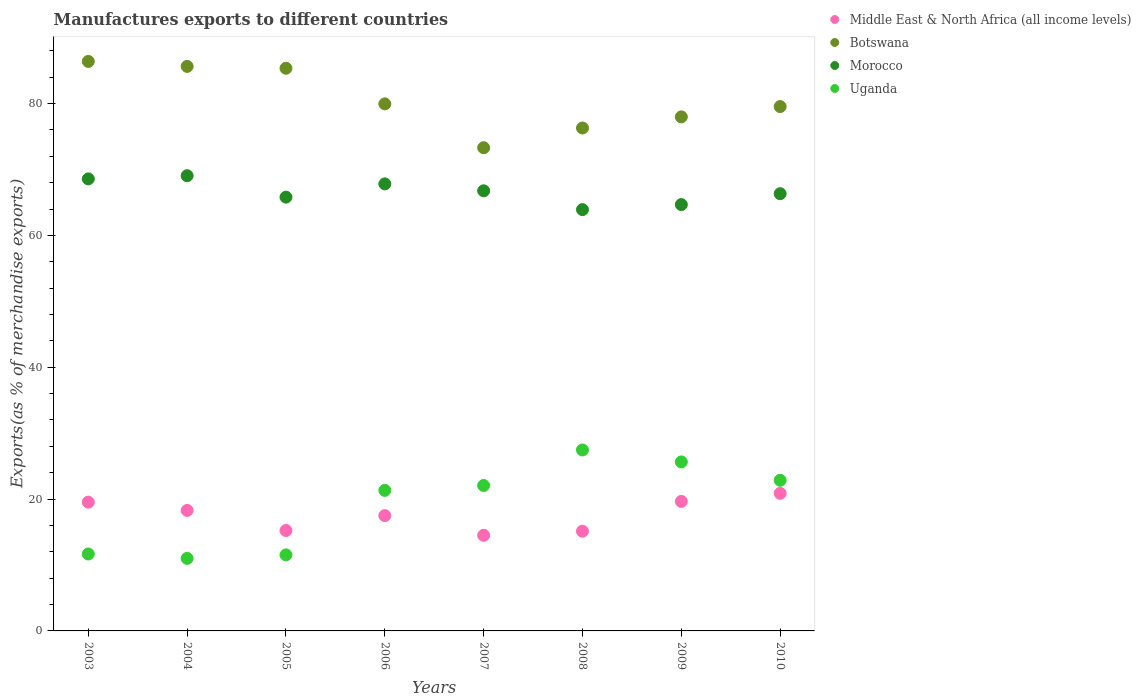Is the number of dotlines equal to the number of legend labels?
Give a very brief answer. Yes. What is the percentage of exports to different countries in Botswana in 2007?
Your answer should be very brief. 73.3. Across all years, what is the maximum percentage of exports to different countries in Botswana?
Offer a terse response. 86.39. Across all years, what is the minimum percentage of exports to different countries in Middle East & North Africa (all income levels)?
Your answer should be very brief. 14.5. What is the total percentage of exports to different countries in Morocco in the graph?
Provide a short and direct response. 532.89. What is the difference between the percentage of exports to different countries in Botswana in 2007 and that in 2008?
Offer a terse response. -2.99. What is the difference between the percentage of exports to different countries in Uganda in 2004 and the percentage of exports to different countries in Morocco in 2005?
Provide a succinct answer. -54.8. What is the average percentage of exports to different countries in Middle East & North Africa (all income levels) per year?
Keep it short and to the point. 17.59. In the year 2004, what is the difference between the percentage of exports to different countries in Middle East & North Africa (all income levels) and percentage of exports to different countries in Uganda?
Offer a very short reply. 7.28. What is the ratio of the percentage of exports to different countries in Uganda in 2005 to that in 2009?
Your answer should be compact. 0.45. Is the percentage of exports to different countries in Botswana in 2004 less than that in 2005?
Your answer should be very brief. No. What is the difference between the highest and the second highest percentage of exports to different countries in Middle East & North Africa (all income levels)?
Your answer should be compact. 1.23. What is the difference between the highest and the lowest percentage of exports to different countries in Middle East & North Africa (all income levels)?
Provide a short and direct response. 6.37. Is the sum of the percentage of exports to different countries in Middle East & North Africa (all income levels) in 2006 and 2008 greater than the maximum percentage of exports to different countries in Botswana across all years?
Give a very brief answer. No. How many years are there in the graph?
Offer a very short reply. 8. How many legend labels are there?
Provide a short and direct response. 4. What is the title of the graph?
Provide a short and direct response. Manufactures exports to different countries. Does "Israel" appear as one of the legend labels in the graph?
Provide a short and direct response. No. What is the label or title of the Y-axis?
Offer a terse response. Exports(as % of merchandise exports). What is the Exports(as % of merchandise exports) in Middle East & North Africa (all income levels) in 2003?
Your response must be concise. 19.53. What is the Exports(as % of merchandise exports) of Botswana in 2003?
Your response must be concise. 86.39. What is the Exports(as % of merchandise exports) in Morocco in 2003?
Your response must be concise. 68.57. What is the Exports(as % of merchandise exports) of Uganda in 2003?
Your response must be concise. 11.67. What is the Exports(as % of merchandise exports) in Middle East & North Africa (all income levels) in 2004?
Your answer should be very brief. 18.28. What is the Exports(as % of merchandise exports) of Botswana in 2004?
Ensure brevity in your answer.  85.63. What is the Exports(as % of merchandise exports) of Morocco in 2004?
Your answer should be compact. 69.05. What is the Exports(as % of merchandise exports) in Uganda in 2004?
Ensure brevity in your answer.  11. What is the Exports(as % of merchandise exports) of Middle East & North Africa (all income levels) in 2005?
Provide a succinct answer. 15.23. What is the Exports(as % of merchandise exports) in Botswana in 2005?
Provide a short and direct response. 85.35. What is the Exports(as % of merchandise exports) in Morocco in 2005?
Your answer should be compact. 65.8. What is the Exports(as % of merchandise exports) of Uganda in 2005?
Give a very brief answer. 11.54. What is the Exports(as % of merchandise exports) in Middle East & North Africa (all income levels) in 2006?
Ensure brevity in your answer.  17.49. What is the Exports(as % of merchandise exports) in Botswana in 2006?
Offer a very short reply. 79.95. What is the Exports(as % of merchandise exports) in Morocco in 2006?
Your answer should be very brief. 67.81. What is the Exports(as % of merchandise exports) in Uganda in 2006?
Keep it short and to the point. 21.32. What is the Exports(as % of merchandise exports) in Middle East & North Africa (all income levels) in 2007?
Give a very brief answer. 14.5. What is the Exports(as % of merchandise exports) in Botswana in 2007?
Offer a terse response. 73.3. What is the Exports(as % of merchandise exports) in Morocco in 2007?
Your answer should be very brief. 66.76. What is the Exports(as % of merchandise exports) of Uganda in 2007?
Your answer should be compact. 22.06. What is the Exports(as % of merchandise exports) of Middle East & North Africa (all income levels) in 2008?
Your answer should be very brief. 15.13. What is the Exports(as % of merchandise exports) in Botswana in 2008?
Offer a very short reply. 76.29. What is the Exports(as % of merchandise exports) in Morocco in 2008?
Give a very brief answer. 63.9. What is the Exports(as % of merchandise exports) in Uganda in 2008?
Give a very brief answer. 27.45. What is the Exports(as % of merchandise exports) of Middle East & North Africa (all income levels) in 2009?
Ensure brevity in your answer.  19.64. What is the Exports(as % of merchandise exports) in Botswana in 2009?
Give a very brief answer. 77.97. What is the Exports(as % of merchandise exports) of Morocco in 2009?
Provide a short and direct response. 64.67. What is the Exports(as % of merchandise exports) of Uganda in 2009?
Your response must be concise. 25.63. What is the Exports(as % of merchandise exports) in Middle East & North Africa (all income levels) in 2010?
Give a very brief answer. 20.87. What is the Exports(as % of merchandise exports) in Botswana in 2010?
Keep it short and to the point. 79.54. What is the Exports(as % of merchandise exports) of Morocco in 2010?
Your response must be concise. 66.32. What is the Exports(as % of merchandise exports) in Uganda in 2010?
Your answer should be compact. 22.85. Across all years, what is the maximum Exports(as % of merchandise exports) in Middle East & North Africa (all income levels)?
Ensure brevity in your answer.  20.87. Across all years, what is the maximum Exports(as % of merchandise exports) of Botswana?
Offer a very short reply. 86.39. Across all years, what is the maximum Exports(as % of merchandise exports) in Morocco?
Provide a short and direct response. 69.05. Across all years, what is the maximum Exports(as % of merchandise exports) in Uganda?
Offer a terse response. 27.45. Across all years, what is the minimum Exports(as % of merchandise exports) in Middle East & North Africa (all income levels)?
Ensure brevity in your answer.  14.5. Across all years, what is the minimum Exports(as % of merchandise exports) of Botswana?
Keep it short and to the point. 73.3. Across all years, what is the minimum Exports(as % of merchandise exports) of Morocco?
Ensure brevity in your answer.  63.9. Across all years, what is the minimum Exports(as % of merchandise exports) in Uganda?
Ensure brevity in your answer.  11. What is the total Exports(as % of merchandise exports) in Middle East & North Africa (all income levels) in the graph?
Make the answer very short. 140.68. What is the total Exports(as % of merchandise exports) of Botswana in the graph?
Make the answer very short. 644.41. What is the total Exports(as % of merchandise exports) of Morocco in the graph?
Give a very brief answer. 532.89. What is the total Exports(as % of merchandise exports) in Uganda in the graph?
Your response must be concise. 153.52. What is the difference between the Exports(as % of merchandise exports) in Middle East & North Africa (all income levels) in 2003 and that in 2004?
Make the answer very short. 1.26. What is the difference between the Exports(as % of merchandise exports) in Botswana in 2003 and that in 2004?
Keep it short and to the point. 0.76. What is the difference between the Exports(as % of merchandise exports) of Morocco in 2003 and that in 2004?
Ensure brevity in your answer.  -0.48. What is the difference between the Exports(as % of merchandise exports) of Uganda in 2003 and that in 2004?
Provide a succinct answer. 0.67. What is the difference between the Exports(as % of merchandise exports) in Middle East & North Africa (all income levels) in 2003 and that in 2005?
Offer a terse response. 4.3. What is the difference between the Exports(as % of merchandise exports) of Botswana in 2003 and that in 2005?
Make the answer very short. 1.04. What is the difference between the Exports(as % of merchandise exports) of Morocco in 2003 and that in 2005?
Offer a terse response. 2.77. What is the difference between the Exports(as % of merchandise exports) in Uganda in 2003 and that in 2005?
Provide a short and direct response. 0.14. What is the difference between the Exports(as % of merchandise exports) of Middle East & North Africa (all income levels) in 2003 and that in 2006?
Offer a terse response. 2.04. What is the difference between the Exports(as % of merchandise exports) of Botswana in 2003 and that in 2006?
Keep it short and to the point. 6.44. What is the difference between the Exports(as % of merchandise exports) in Morocco in 2003 and that in 2006?
Give a very brief answer. 0.76. What is the difference between the Exports(as % of merchandise exports) in Uganda in 2003 and that in 2006?
Provide a succinct answer. -9.65. What is the difference between the Exports(as % of merchandise exports) of Middle East & North Africa (all income levels) in 2003 and that in 2007?
Offer a very short reply. 5.03. What is the difference between the Exports(as % of merchandise exports) of Botswana in 2003 and that in 2007?
Make the answer very short. 13.09. What is the difference between the Exports(as % of merchandise exports) of Morocco in 2003 and that in 2007?
Give a very brief answer. 1.81. What is the difference between the Exports(as % of merchandise exports) of Uganda in 2003 and that in 2007?
Your answer should be very brief. -10.39. What is the difference between the Exports(as % of merchandise exports) of Middle East & North Africa (all income levels) in 2003 and that in 2008?
Offer a terse response. 4.4. What is the difference between the Exports(as % of merchandise exports) in Botswana in 2003 and that in 2008?
Provide a short and direct response. 10.1. What is the difference between the Exports(as % of merchandise exports) of Morocco in 2003 and that in 2008?
Keep it short and to the point. 4.67. What is the difference between the Exports(as % of merchandise exports) in Uganda in 2003 and that in 2008?
Offer a terse response. -15.78. What is the difference between the Exports(as % of merchandise exports) of Middle East & North Africa (all income levels) in 2003 and that in 2009?
Offer a very short reply. -0.11. What is the difference between the Exports(as % of merchandise exports) of Botswana in 2003 and that in 2009?
Offer a very short reply. 8.41. What is the difference between the Exports(as % of merchandise exports) in Morocco in 2003 and that in 2009?
Provide a short and direct response. 3.9. What is the difference between the Exports(as % of merchandise exports) in Uganda in 2003 and that in 2009?
Your response must be concise. -13.96. What is the difference between the Exports(as % of merchandise exports) in Middle East & North Africa (all income levels) in 2003 and that in 2010?
Your response must be concise. -1.34. What is the difference between the Exports(as % of merchandise exports) of Botswana in 2003 and that in 2010?
Ensure brevity in your answer.  6.85. What is the difference between the Exports(as % of merchandise exports) of Morocco in 2003 and that in 2010?
Offer a terse response. 2.25. What is the difference between the Exports(as % of merchandise exports) of Uganda in 2003 and that in 2010?
Your answer should be very brief. -11.18. What is the difference between the Exports(as % of merchandise exports) in Middle East & North Africa (all income levels) in 2004 and that in 2005?
Your answer should be very brief. 3.04. What is the difference between the Exports(as % of merchandise exports) of Botswana in 2004 and that in 2005?
Your answer should be compact. 0.28. What is the difference between the Exports(as % of merchandise exports) in Morocco in 2004 and that in 2005?
Keep it short and to the point. 3.25. What is the difference between the Exports(as % of merchandise exports) in Uganda in 2004 and that in 2005?
Provide a succinct answer. -0.53. What is the difference between the Exports(as % of merchandise exports) in Middle East & North Africa (all income levels) in 2004 and that in 2006?
Give a very brief answer. 0.79. What is the difference between the Exports(as % of merchandise exports) in Botswana in 2004 and that in 2006?
Make the answer very short. 5.68. What is the difference between the Exports(as % of merchandise exports) in Morocco in 2004 and that in 2006?
Keep it short and to the point. 1.24. What is the difference between the Exports(as % of merchandise exports) in Uganda in 2004 and that in 2006?
Your answer should be very brief. -10.32. What is the difference between the Exports(as % of merchandise exports) of Middle East & North Africa (all income levels) in 2004 and that in 2007?
Provide a short and direct response. 3.77. What is the difference between the Exports(as % of merchandise exports) of Botswana in 2004 and that in 2007?
Keep it short and to the point. 12.34. What is the difference between the Exports(as % of merchandise exports) of Morocco in 2004 and that in 2007?
Ensure brevity in your answer.  2.29. What is the difference between the Exports(as % of merchandise exports) of Uganda in 2004 and that in 2007?
Your answer should be very brief. -11.06. What is the difference between the Exports(as % of merchandise exports) of Middle East & North Africa (all income levels) in 2004 and that in 2008?
Keep it short and to the point. 3.15. What is the difference between the Exports(as % of merchandise exports) of Botswana in 2004 and that in 2008?
Give a very brief answer. 9.34. What is the difference between the Exports(as % of merchandise exports) of Morocco in 2004 and that in 2008?
Offer a very short reply. 5.15. What is the difference between the Exports(as % of merchandise exports) in Uganda in 2004 and that in 2008?
Give a very brief answer. -16.45. What is the difference between the Exports(as % of merchandise exports) of Middle East & North Africa (all income levels) in 2004 and that in 2009?
Your answer should be compact. -1.37. What is the difference between the Exports(as % of merchandise exports) in Botswana in 2004 and that in 2009?
Provide a succinct answer. 7.66. What is the difference between the Exports(as % of merchandise exports) of Morocco in 2004 and that in 2009?
Offer a very short reply. 4.38. What is the difference between the Exports(as % of merchandise exports) in Uganda in 2004 and that in 2009?
Offer a very short reply. -14.63. What is the difference between the Exports(as % of merchandise exports) in Middle East & North Africa (all income levels) in 2004 and that in 2010?
Provide a short and direct response. -2.6. What is the difference between the Exports(as % of merchandise exports) in Botswana in 2004 and that in 2010?
Offer a terse response. 6.09. What is the difference between the Exports(as % of merchandise exports) in Morocco in 2004 and that in 2010?
Provide a succinct answer. 2.73. What is the difference between the Exports(as % of merchandise exports) in Uganda in 2004 and that in 2010?
Give a very brief answer. -11.85. What is the difference between the Exports(as % of merchandise exports) in Middle East & North Africa (all income levels) in 2005 and that in 2006?
Your answer should be compact. -2.26. What is the difference between the Exports(as % of merchandise exports) of Botswana in 2005 and that in 2006?
Provide a short and direct response. 5.4. What is the difference between the Exports(as % of merchandise exports) of Morocco in 2005 and that in 2006?
Your answer should be compact. -2.02. What is the difference between the Exports(as % of merchandise exports) of Uganda in 2005 and that in 2006?
Your response must be concise. -9.78. What is the difference between the Exports(as % of merchandise exports) of Middle East & North Africa (all income levels) in 2005 and that in 2007?
Make the answer very short. 0.73. What is the difference between the Exports(as % of merchandise exports) of Botswana in 2005 and that in 2007?
Make the answer very short. 12.05. What is the difference between the Exports(as % of merchandise exports) in Morocco in 2005 and that in 2007?
Provide a succinct answer. -0.96. What is the difference between the Exports(as % of merchandise exports) of Uganda in 2005 and that in 2007?
Give a very brief answer. -10.52. What is the difference between the Exports(as % of merchandise exports) in Middle East & North Africa (all income levels) in 2005 and that in 2008?
Offer a terse response. 0.1. What is the difference between the Exports(as % of merchandise exports) of Botswana in 2005 and that in 2008?
Give a very brief answer. 9.06. What is the difference between the Exports(as % of merchandise exports) of Morocco in 2005 and that in 2008?
Provide a short and direct response. 1.89. What is the difference between the Exports(as % of merchandise exports) of Uganda in 2005 and that in 2008?
Offer a very short reply. -15.91. What is the difference between the Exports(as % of merchandise exports) of Middle East & North Africa (all income levels) in 2005 and that in 2009?
Your answer should be very brief. -4.41. What is the difference between the Exports(as % of merchandise exports) of Botswana in 2005 and that in 2009?
Keep it short and to the point. 7.38. What is the difference between the Exports(as % of merchandise exports) of Morocco in 2005 and that in 2009?
Your answer should be compact. 1.13. What is the difference between the Exports(as % of merchandise exports) in Uganda in 2005 and that in 2009?
Keep it short and to the point. -14.1. What is the difference between the Exports(as % of merchandise exports) in Middle East & North Africa (all income levels) in 2005 and that in 2010?
Provide a short and direct response. -5.64. What is the difference between the Exports(as % of merchandise exports) of Botswana in 2005 and that in 2010?
Offer a very short reply. 5.81. What is the difference between the Exports(as % of merchandise exports) of Morocco in 2005 and that in 2010?
Offer a terse response. -0.52. What is the difference between the Exports(as % of merchandise exports) in Uganda in 2005 and that in 2010?
Offer a very short reply. -11.31. What is the difference between the Exports(as % of merchandise exports) in Middle East & North Africa (all income levels) in 2006 and that in 2007?
Your response must be concise. 2.98. What is the difference between the Exports(as % of merchandise exports) of Botswana in 2006 and that in 2007?
Make the answer very short. 6.65. What is the difference between the Exports(as % of merchandise exports) in Morocco in 2006 and that in 2007?
Give a very brief answer. 1.05. What is the difference between the Exports(as % of merchandise exports) of Uganda in 2006 and that in 2007?
Your answer should be very brief. -0.74. What is the difference between the Exports(as % of merchandise exports) of Middle East & North Africa (all income levels) in 2006 and that in 2008?
Your answer should be compact. 2.36. What is the difference between the Exports(as % of merchandise exports) in Botswana in 2006 and that in 2008?
Your response must be concise. 3.66. What is the difference between the Exports(as % of merchandise exports) in Morocco in 2006 and that in 2008?
Offer a terse response. 3.91. What is the difference between the Exports(as % of merchandise exports) in Uganda in 2006 and that in 2008?
Your answer should be compact. -6.13. What is the difference between the Exports(as % of merchandise exports) of Middle East & North Africa (all income levels) in 2006 and that in 2009?
Ensure brevity in your answer.  -2.16. What is the difference between the Exports(as % of merchandise exports) of Botswana in 2006 and that in 2009?
Ensure brevity in your answer.  1.97. What is the difference between the Exports(as % of merchandise exports) of Morocco in 2006 and that in 2009?
Keep it short and to the point. 3.14. What is the difference between the Exports(as % of merchandise exports) in Uganda in 2006 and that in 2009?
Offer a terse response. -4.31. What is the difference between the Exports(as % of merchandise exports) in Middle East & North Africa (all income levels) in 2006 and that in 2010?
Offer a very short reply. -3.38. What is the difference between the Exports(as % of merchandise exports) of Botswana in 2006 and that in 2010?
Make the answer very short. 0.41. What is the difference between the Exports(as % of merchandise exports) in Morocco in 2006 and that in 2010?
Offer a terse response. 1.49. What is the difference between the Exports(as % of merchandise exports) in Uganda in 2006 and that in 2010?
Give a very brief answer. -1.53. What is the difference between the Exports(as % of merchandise exports) in Middle East & North Africa (all income levels) in 2007 and that in 2008?
Your response must be concise. -0.62. What is the difference between the Exports(as % of merchandise exports) in Botswana in 2007 and that in 2008?
Make the answer very short. -2.99. What is the difference between the Exports(as % of merchandise exports) of Morocco in 2007 and that in 2008?
Ensure brevity in your answer.  2.86. What is the difference between the Exports(as % of merchandise exports) in Uganda in 2007 and that in 2008?
Ensure brevity in your answer.  -5.39. What is the difference between the Exports(as % of merchandise exports) of Middle East & North Africa (all income levels) in 2007 and that in 2009?
Ensure brevity in your answer.  -5.14. What is the difference between the Exports(as % of merchandise exports) of Botswana in 2007 and that in 2009?
Provide a short and direct response. -4.68. What is the difference between the Exports(as % of merchandise exports) of Morocco in 2007 and that in 2009?
Offer a terse response. 2.09. What is the difference between the Exports(as % of merchandise exports) of Uganda in 2007 and that in 2009?
Your response must be concise. -3.58. What is the difference between the Exports(as % of merchandise exports) in Middle East & North Africa (all income levels) in 2007 and that in 2010?
Your answer should be compact. -6.37. What is the difference between the Exports(as % of merchandise exports) in Botswana in 2007 and that in 2010?
Give a very brief answer. -6.24. What is the difference between the Exports(as % of merchandise exports) in Morocco in 2007 and that in 2010?
Your answer should be very brief. 0.44. What is the difference between the Exports(as % of merchandise exports) in Uganda in 2007 and that in 2010?
Your response must be concise. -0.79. What is the difference between the Exports(as % of merchandise exports) of Middle East & North Africa (all income levels) in 2008 and that in 2009?
Give a very brief answer. -4.52. What is the difference between the Exports(as % of merchandise exports) in Botswana in 2008 and that in 2009?
Provide a short and direct response. -1.69. What is the difference between the Exports(as % of merchandise exports) of Morocco in 2008 and that in 2009?
Give a very brief answer. -0.77. What is the difference between the Exports(as % of merchandise exports) of Uganda in 2008 and that in 2009?
Give a very brief answer. 1.82. What is the difference between the Exports(as % of merchandise exports) in Middle East & North Africa (all income levels) in 2008 and that in 2010?
Provide a succinct answer. -5.74. What is the difference between the Exports(as % of merchandise exports) in Botswana in 2008 and that in 2010?
Keep it short and to the point. -3.25. What is the difference between the Exports(as % of merchandise exports) in Morocco in 2008 and that in 2010?
Ensure brevity in your answer.  -2.42. What is the difference between the Exports(as % of merchandise exports) in Uganda in 2008 and that in 2010?
Provide a succinct answer. 4.6. What is the difference between the Exports(as % of merchandise exports) of Middle East & North Africa (all income levels) in 2009 and that in 2010?
Provide a succinct answer. -1.23. What is the difference between the Exports(as % of merchandise exports) in Botswana in 2009 and that in 2010?
Your answer should be very brief. -1.56. What is the difference between the Exports(as % of merchandise exports) in Morocco in 2009 and that in 2010?
Make the answer very short. -1.65. What is the difference between the Exports(as % of merchandise exports) of Uganda in 2009 and that in 2010?
Ensure brevity in your answer.  2.79. What is the difference between the Exports(as % of merchandise exports) of Middle East & North Africa (all income levels) in 2003 and the Exports(as % of merchandise exports) of Botswana in 2004?
Keep it short and to the point. -66.1. What is the difference between the Exports(as % of merchandise exports) of Middle East & North Africa (all income levels) in 2003 and the Exports(as % of merchandise exports) of Morocco in 2004?
Your response must be concise. -49.52. What is the difference between the Exports(as % of merchandise exports) of Middle East & North Africa (all income levels) in 2003 and the Exports(as % of merchandise exports) of Uganda in 2004?
Offer a terse response. 8.53. What is the difference between the Exports(as % of merchandise exports) in Botswana in 2003 and the Exports(as % of merchandise exports) in Morocco in 2004?
Make the answer very short. 17.34. What is the difference between the Exports(as % of merchandise exports) of Botswana in 2003 and the Exports(as % of merchandise exports) of Uganda in 2004?
Your answer should be compact. 75.39. What is the difference between the Exports(as % of merchandise exports) in Morocco in 2003 and the Exports(as % of merchandise exports) in Uganda in 2004?
Make the answer very short. 57.57. What is the difference between the Exports(as % of merchandise exports) of Middle East & North Africa (all income levels) in 2003 and the Exports(as % of merchandise exports) of Botswana in 2005?
Keep it short and to the point. -65.82. What is the difference between the Exports(as % of merchandise exports) in Middle East & North Africa (all income levels) in 2003 and the Exports(as % of merchandise exports) in Morocco in 2005?
Offer a terse response. -46.26. What is the difference between the Exports(as % of merchandise exports) in Middle East & North Africa (all income levels) in 2003 and the Exports(as % of merchandise exports) in Uganda in 2005?
Offer a very short reply. 8. What is the difference between the Exports(as % of merchandise exports) of Botswana in 2003 and the Exports(as % of merchandise exports) of Morocco in 2005?
Offer a very short reply. 20.59. What is the difference between the Exports(as % of merchandise exports) in Botswana in 2003 and the Exports(as % of merchandise exports) in Uganda in 2005?
Make the answer very short. 74.85. What is the difference between the Exports(as % of merchandise exports) of Morocco in 2003 and the Exports(as % of merchandise exports) of Uganda in 2005?
Offer a very short reply. 57.03. What is the difference between the Exports(as % of merchandise exports) of Middle East & North Africa (all income levels) in 2003 and the Exports(as % of merchandise exports) of Botswana in 2006?
Your answer should be compact. -60.41. What is the difference between the Exports(as % of merchandise exports) of Middle East & North Africa (all income levels) in 2003 and the Exports(as % of merchandise exports) of Morocco in 2006?
Your answer should be very brief. -48.28. What is the difference between the Exports(as % of merchandise exports) of Middle East & North Africa (all income levels) in 2003 and the Exports(as % of merchandise exports) of Uganda in 2006?
Offer a terse response. -1.79. What is the difference between the Exports(as % of merchandise exports) in Botswana in 2003 and the Exports(as % of merchandise exports) in Morocco in 2006?
Give a very brief answer. 18.57. What is the difference between the Exports(as % of merchandise exports) of Botswana in 2003 and the Exports(as % of merchandise exports) of Uganda in 2006?
Provide a short and direct response. 65.07. What is the difference between the Exports(as % of merchandise exports) of Morocco in 2003 and the Exports(as % of merchandise exports) of Uganda in 2006?
Your response must be concise. 47.25. What is the difference between the Exports(as % of merchandise exports) in Middle East & North Africa (all income levels) in 2003 and the Exports(as % of merchandise exports) in Botswana in 2007?
Offer a very short reply. -53.76. What is the difference between the Exports(as % of merchandise exports) in Middle East & North Africa (all income levels) in 2003 and the Exports(as % of merchandise exports) in Morocco in 2007?
Provide a short and direct response. -47.23. What is the difference between the Exports(as % of merchandise exports) in Middle East & North Africa (all income levels) in 2003 and the Exports(as % of merchandise exports) in Uganda in 2007?
Your answer should be compact. -2.53. What is the difference between the Exports(as % of merchandise exports) in Botswana in 2003 and the Exports(as % of merchandise exports) in Morocco in 2007?
Offer a terse response. 19.63. What is the difference between the Exports(as % of merchandise exports) in Botswana in 2003 and the Exports(as % of merchandise exports) in Uganda in 2007?
Keep it short and to the point. 64.33. What is the difference between the Exports(as % of merchandise exports) in Morocco in 2003 and the Exports(as % of merchandise exports) in Uganda in 2007?
Your answer should be very brief. 46.51. What is the difference between the Exports(as % of merchandise exports) of Middle East & North Africa (all income levels) in 2003 and the Exports(as % of merchandise exports) of Botswana in 2008?
Make the answer very short. -56.75. What is the difference between the Exports(as % of merchandise exports) in Middle East & North Africa (all income levels) in 2003 and the Exports(as % of merchandise exports) in Morocco in 2008?
Give a very brief answer. -44.37. What is the difference between the Exports(as % of merchandise exports) in Middle East & North Africa (all income levels) in 2003 and the Exports(as % of merchandise exports) in Uganda in 2008?
Offer a terse response. -7.92. What is the difference between the Exports(as % of merchandise exports) of Botswana in 2003 and the Exports(as % of merchandise exports) of Morocco in 2008?
Provide a succinct answer. 22.48. What is the difference between the Exports(as % of merchandise exports) of Botswana in 2003 and the Exports(as % of merchandise exports) of Uganda in 2008?
Provide a short and direct response. 58.94. What is the difference between the Exports(as % of merchandise exports) in Morocco in 2003 and the Exports(as % of merchandise exports) in Uganda in 2008?
Your response must be concise. 41.12. What is the difference between the Exports(as % of merchandise exports) in Middle East & North Africa (all income levels) in 2003 and the Exports(as % of merchandise exports) in Botswana in 2009?
Keep it short and to the point. -58.44. What is the difference between the Exports(as % of merchandise exports) in Middle East & North Africa (all income levels) in 2003 and the Exports(as % of merchandise exports) in Morocco in 2009?
Offer a very short reply. -45.14. What is the difference between the Exports(as % of merchandise exports) in Middle East & North Africa (all income levels) in 2003 and the Exports(as % of merchandise exports) in Uganda in 2009?
Your answer should be compact. -6.1. What is the difference between the Exports(as % of merchandise exports) in Botswana in 2003 and the Exports(as % of merchandise exports) in Morocco in 2009?
Give a very brief answer. 21.72. What is the difference between the Exports(as % of merchandise exports) of Botswana in 2003 and the Exports(as % of merchandise exports) of Uganda in 2009?
Give a very brief answer. 60.75. What is the difference between the Exports(as % of merchandise exports) in Morocco in 2003 and the Exports(as % of merchandise exports) in Uganda in 2009?
Your answer should be very brief. 42.94. What is the difference between the Exports(as % of merchandise exports) in Middle East & North Africa (all income levels) in 2003 and the Exports(as % of merchandise exports) in Botswana in 2010?
Your response must be concise. -60. What is the difference between the Exports(as % of merchandise exports) in Middle East & North Africa (all income levels) in 2003 and the Exports(as % of merchandise exports) in Morocco in 2010?
Keep it short and to the point. -46.79. What is the difference between the Exports(as % of merchandise exports) of Middle East & North Africa (all income levels) in 2003 and the Exports(as % of merchandise exports) of Uganda in 2010?
Your answer should be compact. -3.32. What is the difference between the Exports(as % of merchandise exports) of Botswana in 2003 and the Exports(as % of merchandise exports) of Morocco in 2010?
Keep it short and to the point. 20.06. What is the difference between the Exports(as % of merchandise exports) of Botswana in 2003 and the Exports(as % of merchandise exports) of Uganda in 2010?
Offer a terse response. 63.54. What is the difference between the Exports(as % of merchandise exports) of Morocco in 2003 and the Exports(as % of merchandise exports) of Uganda in 2010?
Provide a short and direct response. 45.72. What is the difference between the Exports(as % of merchandise exports) of Middle East & North Africa (all income levels) in 2004 and the Exports(as % of merchandise exports) of Botswana in 2005?
Your answer should be compact. -67.07. What is the difference between the Exports(as % of merchandise exports) of Middle East & North Africa (all income levels) in 2004 and the Exports(as % of merchandise exports) of Morocco in 2005?
Make the answer very short. -47.52. What is the difference between the Exports(as % of merchandise exports) in Middle East & North Africa (all income levels) in 2004 and the Exports(as % of merchandise exports) in Uganda in 2005?
Provide a short and direct response. 6.74. What is the difference between the Exports(as % of merchandise exports) in Botswana in 2004 and the Exports(as % of merchandise exports) in Morocco in 2005?
Give a very brief answer. 19.83. What is the difference between the Exports(as % of merchandise exports) in Botswana in 2004 and the Exports(as % of merchandise exports) in Uganda in 2005?
Keep it short and to the point. 74.09. What is the difference between the Exports(as % of merchandise exports) in Morocco in 2004 and the Exports(as % of merchandise exports) in Uganda in 2005?
Provide a succinct answer. 57.52. What is the difference between the Exports(as % of merchandise exports) of Middle East & North Africa (all income levels) in 2004 and the Exports(as % of merchandise exports) of Botswana in 2006?
Provide a short and direct response. -61.67. What is the difference between the Exports(as % of merchandise exports) in Middle East & North Africa (all income levels) in 2004 and the Exports(as % of merchandise exports) in Morocco in 2006?
Make the answer very short. -49.53. What is the difference between the Exports(as % of merchandise exports) of Middle East & North Africa (all income levels) in 2004 and the Exports(as % of merchandise exports) of Uganda in 2006?
Offer a terse response. -3.04. What is the difference between the Exports(as % of merchandise exports) in Botswana in 2004 and the Exports(as % of merchandise exports) in Morocco in 2006?
Your answer should be compact. 17.82. What is the difference between the Exports(as % of merchandise exports) of Botswana in 2004 and the Exports(as % of merchandise exports) of Uganda in 2006?
Provide a succinct answer. 64.31. What is the difference between the Exports(as % of merchandise exports) in Morocco in 2004 and the Exports(as % of merchandise exports) in Uganda in 2006?
Your answer should be compact. 47.73. What is the difference between the Exports(as % of merchandise exports) in Middle East & North Africa (all income levels) in 2004 and the Exports(as % of merchandise exports) in Botswana in 2007?
Your answer should be compact. -55.02. What is the difference between the Exports(as % of merchandise exports) of Middle East & North Africa (all income levels) in 2004 and the Exports(as % of merchandise exports) of Morocco in 2007?
Offer a terse response. -48.48. What is the difference between the Exports(as % of merchandise exports) in Middle East & North Africa (all income levels) in 2004 and the Exports(as % of merchandise exports) in Uganda in 2007?
Offer a terse response. -3.78. What is the difference between the Exports(as % of merchandise exports) in Botswana in 2004 and the Exports(as % of merchandise exports) in Morocco in 2007?
Your answer should be very brief. 18.87. What is the difference between the Exports(as % of merchandise exports) in Botswana in 2004 and the Exports(as % of merchandise exports) in Uganda in 2007?
Provide a succinct answer. 63.57. What is the difference between the Exports(as % of merchandise exports) of Morocco in 2004 and the Exports(as % of merchandise exports) of Uganda in 2007?
Keep it short and to the point. 46.99. What is the difference between the Exports(as % of merchandise exports) in Middle East & North Africa (all income levels) in 2004 and the Exports(as % of merchandise exports) in Botswana in 2008?
Your response must be concise. -58.01. What is the difference between the Exports(as % of merchandise exports) of Middle East & North Africa (all income levels) in 2004 and the Exports(as % of merchandise exports) of Morocco in 2008?
Offer a terse response. -45.63. What is the difference between the Exports(as % of merchandise exports) of Middle East & North Africa (all income levels) in 2004 and the Exports(as % of merchandise exports) of Uganda in 2008?
Provide a succinct answer. -9.17. What is the difference between the Exports(as % of merchandise exports) in Botswana in 2004 and the Exports(as % of merchandise exports) in Morocco in 2008?
Offer a very short reply. 21.73. What is the difference between the Exports(as % of merchandise exports) in Botswana in 2004 and the Exports(as % of merchandise exports) in Uganda in 2008?
Offer a very short reply. 58.18. What is the difference between the Exports(as % of merchandise exports) of Morocco in 2004 and the Exports(as % of merchandise exports) of Uganda in 2008?
Provide a short and direct response. 41.6. What is the difference between the Exports(as % of merchandise exports) of Middle East & North Africa (all income levels) in 2004 and the Exports(as % of merchandise exports) of Botswana in 2009?
Provide a succinct answer. -59.7. What is the difference between the Exports(as % of merchandise exports) of Middle East & North Africa (all income levels) in 2004 and the Exports(as % of merchandise exports) of Morocco in 2009?
Provide a succinct answer. -46.39. What is the difference between the Exports(as % of merchandise exports) of Middle East & North Africa (all income levels) in 2004 and the Exports(as % of merchandise exports) of Uganda in 2009?
Ensure brevity in your answer.  -7.36. What is the difference between the Exports(as % of merchandise exports) of Botswana in 2004 and the Exports(as % of merchandise exports) of Morocco in 2009?
Provide a succinct answer. 20.96. What is the difference between the Exports(as % of merchandise exports) of Botswana in 2004 and the Exports(as % of merchandise exports) of Uganda in 2009?
Offer a very short reply. 60. What is the difference between the Exports(as % of merchandise exports) of Morocco in 2004 and the Exports(as % of merchandise exports) of Uganda in 2009?
Provide a succinct answer. 43.42. What is the difference between the Exports(as % of merchandise exports) of Middle East & North Africa (all income levels) in 2004 and the Exports(as % of merchandise exports) of Botswana in 2010?
Keep it short and to the point. -61.26. What is the difference between the Exports(as % of merchandise exports) of Middle East & North Africa (all income levels) in 2004 and the Exports(as % of merchandise exports) of Morocco in 2010?
Make the answer very short. -48.04. What is the difference between the Exports(as % of merchandise exports) of Middle East & North Africa (all income levels) in 2004 and the Exports(as % of merchandise exports) of Uganda in 2010?
Your answer should be very brief. -4.57. What is the difference between the Exports(as % of merchandise exports) of Botswana in 2004 and the Exports(as % of merchandise exports) of Morocco in 2010?
Your response must be concise. 19.31. What is the difference between the Exports(as % of merchandise exports) in Botswana in 2004 and the Exports(as % of merchandise exports) in Uganda in 2010?
Give a very brief answer. 62.78. What is the difference between the Exports(as % of merchandise exports) in Morocco in 2004 and the Exports(as % of merchandise exports) in Uganda in 2010?
Your answer should be very brief. 46.2. What is the difference between the Exports(as % of merchandise exports) of Middle East & North Africa (all income levels) in 2005 and the Exports(as % of merchandise exports) of Botswana in 2006?
Offer a terse response. -64.71. What is the difference between the Exports(as % of merchandise exports) in Middle East & North Africa (all income levels) in 2005 and the Exports(as % of merchandise exports) in Morocco in 2006?
Your response must be concise. -52.58. What is the difference between the Exports(as % of merchandise exports) of Middle East & North Africa (all income levels) in 2005 and the Exports(as % of merchandise exports) of Uganda in 2006?
Make the answer very short. -6.09. What is the difference between the Exports(as % of merchandise exports) of Botswana in 2005 and the Exports(as % of merchandise exports) of Morocco in 2006?
Your response must be concise. 17.54. What is the difference between the Exports(as % of merchandise exports) in Botswana in 2005 and the Exports(as % of merchandise exports) in Uganda in 2006?
Your answer should be compact. 64.03. What is the difference between the Exports(as % of merchandise exports) of Morocco in 2005 and the Exports(as % of merchandise exports) of Uganda in 2006?
Provide a succinct answer. 44.48. What is the difference between the Exports(as % of merchandise exports) of Middle East & North Africa (all income levels) in 2005 and the Exports(as % of merchandise exports) of Botswana in 2007?
Your response must be concise. -58.06. What is the difference between the Exports(as % of merchandise exports) in Middle East & North Africa (all income levels) in 2005 and the Exports(as % of merchandise exports) in Morocco in 2007?
Your answer should be compact. -51.53. What is the difference between the Exports(as % of merchandise exports) in Middle East & North Africa (all income levels) in 2005 and the Exports(as % of merchandise exports) in Uganda in 2007?
Provide a succinct answer. -6.83. What is the difference between the Exports(as % of merchandise exports) of Botswana in 2005 and the Exports(as % of merchandise exports) of Morocco in 2007?
Your response must be concise. 18.59. What is the difference between the Exports(as % of merchandise exports) of Botswana in 2005 and the Exports(as % of merchandise exports) of Uganda in 2007?
Your response must be concise. 63.29. What is the difference between the Exports(as % of merchandise exports) of Morocco in 2005 and the Exports(as % of merchandise exports) of Uganda in 2007?
Offer a very short reply. 43.74. What is the difference between the Exports(as % of merchandise exports) of Middle East & North Africa (all income levels) in 2005 and the Exports(as % of merchandise exports) of Botswana in 2008?
Offer a terse response. -61.05. What is the difference between the Exports(as % of merchandise exports) in Middle East & North Africa (all income levels) in 2005 and the Exports(as % of merchandise exports) in Morocco in 2008?
Offer a very short reply. -48.67. What is the difference between the Exports(as % of merchandise exports) in Middle East & North Africa (all income levels) in 2005 and the Exports(as % of merchandise exports) in Uganda in 2008?
Make the answer very short. -12.22. What is the difference between the Exports(as % of merchandise exports) in Botswana in 2005 and the Exports(as % of merchandise exports) in Morocco in 2008?
Provide a short and direct response. 21.45. What is the difference between the Exports(as % of merchandise exports) in Botswana in 2005 and the Exports(as % of merchandise exports) in Uganda in 2008?
Offer a very short reply. 57.9. What is the difference between the Exports(as % of merchandise exports) in Morocco in 2005 and the Exports(as % of merchandise exports) in Uganda in 2008?
Make the answer very short. 38.35. What is the difference between the Exports(as % of merchandise exports) in Middle East & North Africa (all income levels) in 2005 and the Exports(as % of merchandise exports) in Botswana in 2009?
Provide a succinct answer. -62.74. What is the difference between the Exports(as % of merchandise exports) of Middle East & North Africa (all income levels) in 2005 and the Exports(as % of merchandise exports) of Morocco in 2009?
Your response must be concise. -49.44. What is the difference between the Exports(as % of merchandise exports) in Middle East & North Africa (all income levels) in 2005 and the Exports(as % of merchandise exports) in Uganda in 2009?
Your response must be concise. -10.4. What is the difference between the Exports(as % of merchandise exports) in Botswana in 2005 and the Exports(as % of merchandise exports) in Morocco in 2009?
Keep it short and to the point. 20.68. What is the difference between the Exports(as % of merchandise exports) in Botswana in 2005 and the Exports(as % of merchandise exports) in Uganda in 2009?
Your answer should be very brief. 59.72. What is the difference between the Exports(as % of merchandise exports) in Morocco in 2005 and the Exports(as % of merchandise exports) in Uganda in 2009?
Your response must be concise. 40.16. What is the difference between the Exports(as % of merchandise exports) in Middle East & North Africa (all income levels) in 2005 and the Exports(as % of merchandise exports) in Botswana in 2010?
Your answer should be very brief. -64.3. What is the difference between the Exports(as % of merchandise exports) in Middle East & North Africa (all income levels) in 2005 and the Exports(as % of merchandise exports) in Morocco in 2010?
Offer a terse response. -51.09. What is the difference between the Exports(as % of merchandise exports) of Middle East & North Africa (all income levels) in 2005 and the Exports(as % of merchandise exports) of Uganda in 2010?
Provide a short and direct response. -7.62. What is the difference between the Exports(as % of merchandise exports) in Botswana in 2005 and the Exports(as % of merchandise exports) in Morocco in 2010?
Offer a terse response. 19.03. What is the difference between the Exports(as % of merchandise exports) of Botswana in 2005 and the Exports(as % of merchandise exports) of Uganda in 2010?
Your answer should be very brief. 62.5. What is the difference between the Exports(as % of merchandise exports) in Morocco in 2005 and the Exports(as % of merchandise exports) in Uganda in 2010?
Make the answer very short. 42.95. What is the difference between the Exports(as % of merchandise exports) of Middle East & North Africa (all income levels) in 2006 and the Exports(as % of merchandise exports) of Botswana in 2007?
Keep it short and to the point. -55.81. What is the difference between the Exports(as % of merchandise exports) of Middle East & North Africa (all income levels) in 2006 and the Exports(as % of merchandise exports) of Morocco in 2007?
Ensure brevity in your answer.  -49.27. What is the difference between the Exports(as % of merchandise exports) in Middle East & North Africa (all income levels) in 2006 and the Exports(as % of merchandise exports) in Uganda in 2007?
Keep it short and to the point. -4.57. What is the difference between the Exports(as % of merchandise exports) of Botswana in 2006 and the Exports(as % of merchandise exports) of Morocco in 2007?
Provide a short and direct response. 13.19. What is the difference between the Exports(as % of merchandise exports) of Botswana in 2006 and the Exports(as % of merchandise exports) of Uganda in 2007?
Your response must be concise. 57.89. What is the difference between the Exports(as % of merchandise exports) of Morocco in 2006 and the Exports(as % of merchandise exports) of Uganda in 2007?
Give a very brief answer. 45.75. What is the difference between the Exports(as % of merchandise exports) in Middle East & North Africa (all income levels) in 2006 and the Exports(as % of merchandise exports) in Botswana in 2008?
Provide a succinct answer. -58.8. What is the difference between the Exports(as % of merchandise exports) of Middle East & North Africa (all income levels) in 2006 and the Exports(as % of merchandise exports) of Morocco in 2008?
Give a very brief answer. -46.41. What is the difference between the Exports(as % of merchandise exports) of Middle East & North Africa (all income levels) in 2006 and the Exports(as % of merchandise exports) of Uganda in 2008?
Your answer should be compact. -9.96. What is the difference between the Exports(as % of merchandise exports) of Botswana in 2006 and the Exports(as % of merchandise exports) of Morocco in 2008?
Give a very brief answer. 16.04. What is the difference between the Exports(as % of merchandise exports) of Botswana in 2006 and the Exports(as % of merchandise exports) of Uganda in 2008?
Give a very brief answer. 52.5. What is the difference between the Exports(as % of merchandise exports) in Morocco in 2006 and the Exports(as % of merchandise exports) in Uganda in 2008?
Ensure brevity in your answer.  40.36. What is the difference between the Exports(as % of merchandise exports) of Middle East & North Africa (all income levels) in 2006 and the Exports(as % of merchandise exports) of Botswana in 2009?
Give a very brief answer. -60.49. What is the difference between the Exports(as % of merchandise exports) of Middle East & North Africa (all income levels) in 2006 and the Exports(as % of merchandise exports) of Morocco in 2009?
Your response must be concise. -47.18. What is the difference between the Exports(as % of merchandise exports) in Middle East & North Africa (all income levels) in 2006 and the Exports(as % of merchandise exports) in Uganda in 2009?
Your answer should be compact. -8.15. What is the difference between the Exports(as % of merchandise exports) of Botswana in 2006 and the Exports(as % of merchandise exports) of Morocco in 2009?
Your answer should be compact. 15.28. What is the difference between the Exports(as % of merchandise exports) in Botswana in 2006 and the Exports(as % of merchandise exports) in Uganda in 2009?
Provide a short and direct response. 54.31. What is the difference between the Exports(as % of merchandise exports) of Morocco in 2006 and the Exports(as % of merchandise exports) of Uganda in 2009?
Give a very brief answer. 42.18. What is the difference between the Exports(as % of merchandise exports) of Middle East & North Africa (all income levels) in 2006 and the Exports(as % of merchandise exports) of Botswana in 2010?
Your answer should be compact. -62.05. What is the difference between the Exports(as % of merchandise exports) in Middle East & North Africa (all income levels) in 2006 and the Exports(as % of merchandise exports) in Morocco in 2010?
Your answer should be compact. -48.83. What is the difference between the Exports(as % of merchandise exports) of Middle East & North Africa (all income levels) in 2006 and the Exports(as % of merchandise exports) of Uganda in 2010?
Provide a short and direct response. -5.36. What is the difference between the Exports(as % of merchandise exports) in Botswana in 2006 and the Exports(as % of merchandise exports) in Morocco in 2010?
Offer a terse response. 13.62. What is the difference between the Exports(as % of merchandise exports) of Botswana in 2006 and the Exports(as % of merchandise exports) of Uganda in 2010?
Give a very brief answer. 57.1. What is the difference between the Exports(as % of merchandise exports) in Morocco in 2006 and the Exports(as % of merchandise exports) in Uganda in 2010?
Ensure brevity in your answer.  44.96. What is the difference between the Exports(as % of merchandise exports) of Middle East & North Africa (all income levels) in 2007 and the Exports(as % of merchandise exports) of Botswana in 2008?
Offer a very short reply. -61.78. What is the difference between the Exports(as % of merchandise exports) in Middle East & North Africa (all income levels) in 2007 and the Exports(as % of merchandise exports) in Morocco in 2008?
Your answer should be compact. -49.4. What is the difference between the Exports(as % of merchandise exports) of Middle East & North Africa (all income levels) in 2007 and the Exports(as % of merchandise exports) of Uganda in 2008?
Give a very brief answer. -12.95. What is the difference between the Exports(as % of merchandise exports) of Botswana in 2007 and the Exports(as % of merchandise exports) of Morocco in 2008?
Offer a terse response. 9.39. What is the difference between the Exports(as % of merchandise exports) of Botswana in 2007 and the Exports(as % of merchandise exports) of Uganda in 2008?
Your answer should be very brief. 45.85. What is the difference between the Exports(as % of merchandise exports) of Morocco in 2007 and the Exports(as % of merchandise exports) of Uganda in 2008?
Your answer should be very brief. 39.31. What is the difference between the Exports(as % of merchandise exports) of Middle East & North Africa (all income levels) in 2007 and the Exports(as % of merchandise exports) of Botswana in 2009?
Your answer should be compact. -63.47. What is the difference between the Exports(as % of merchandise exports) of Middle East & North Africa (all income levels) in 2007 and the Exports(as % of merchandise exports) of Morocco in 2009?
Provide a succinct answer. -50.17. What is the difference between the Exports(as % of merchandise exports) in Middle East & North Africa (all income levels) in 2007 and the Exports(as % of merchandise exports) in Uganda in 2009?
Offer a terse response. -11.13. What is the difference between the Exports(as % of merchandise exports) in Botswana in 2007 and the Exports(as % of merchandise exports) in Morocco in 2009?
Provide a succinct answer. 8.62. What is the difference between the Exports(as % of merchandise exports) of Botswana in 2007 and the Exports(as % of merchandise exports) of Uganda in 2009?
Your answer should be very brief. 47.66. What is the difference between the Exports(as % of merchandise exports) in Morocco in 2007 and the Exports(as % of merchandise exports) in Uganda in 2009?
Ensure brevity in your answer.  41.13. What is the difference between the Exports(as % of merchandise exports) of Middle East & North Africa (all income levels) in 2007 and the Exports(as % of merchandise exports) of Botswana in 2010?
Offer a very short reply. -65.03. What is the difference between the Exports(as % of merchandise exports) in Middle East & North Africa (all income levels) in 2007 and the Exports(as % of merchandise exports) in Morocco in 2010?
Provide a short and direct response. -51.82. What is the difference between the Exports(as % of merchandise exports) in Middle East & North Africa (all income levels) in 2007 and the Exports(as % of merchandise exports) in Uganda in 2010?
Your response must be concise. -8.35. What is the difference between the Exports(as % of merchandise exports) of Botswana in 2007 and the Exports(as % of merchandise exports) of Morocco in 2010?
Your response must be concise. 6.97. What is the difference between the Exports(as % of merchandise exports) in Botswana in 2007 and the Exports(as % of merchandise exports) in Uganda in 2010?
Make the answer very short. 50.45. What is the difference between the Exports(as % of merchandise exports) in Morocco in 2007 and the Exports(as % of merchandise exports) in Uganda in 2010?
Keep it short and to the point. 43.91. What is the difference between the Exports(as % of merchandise exports) of Middle East & North Africa (all income levels) in 2008 and the Exports(as % of merchandise exports) of Botswana in 2009?
Make the answer very short. -62.85. What is the difference between the Exports(as % of merchandise exports) of Middle East & North Africa (all income levels) in 2008 and the Exports(as % of merchandise exports) of Morocco in 2009?
Your response must be concise. -49.54. What is the difference between the Exports(as % of merchandise exports) in Middle East & North Africa (all income levels) in 2008 and the Exports(as % of merchandise exports) in Uganda in 2009?
Your response must be concise. -10.51. What is the difference between the Exports(as % of merchandise exports) in Botswana in 2008 and the Exports(as % of merchandise exports) in Morocco in 2009?
Your answer should be compact. 11.62. What is the difference between the Exports(as % of merchandise exports) of Botswana in 2008 and the Exports(as % of merchandise exports) of Uganda in 2009?
Ensure brevity in your answer.  50.65. What is the difference between the Exports(as % of merchandise exports) of Morocco in 2008 and the Exports(as % of merchandise exports) of Uganda in 2009?
Your answer should be very brief. 38.27. What is the difference between the Exports(as % of merchandise exports) of Middle East & North Africa (all income levels) in 2008 and the Exports(as % of merchandise exports) of Botswana in 2010?
Ensure brevity in your answer.  -64.41. What is the difference between the Exports(as % of merchandise exports) of Middle East & North Africa (all income levels) in 2008 and the Exports(as % of merchandise exports) of Morocco in 2010?
Keep it short and to the point. -51.19. What is the difference between the Exports(as % of merchandise exports) of Middle East & North Africa (all income levels) in 2008 and the Exports(as % of merchandise exports) of Uganda in 2010?
Your answer should be compact. -7.72. What is the difference between the Exports(as % of merchandise exports) of Botswana in 2008 and the Exports(as % of merchandise exports) of Morocco in 2010?
Give a very brief answer. 9.96. What is the difference between the Exports(as % of merchandise exports) in Botswana in 2008 and the Exports(as % of merchandise exports) in Uganda in 2010?
Keep it short and to the point. 53.44. What is the difference between the Exports(as % of merchandise exports) in Morocco in 2008 and the Exports(as % of merchandise exports) in Uganda in 2010?
Your answer should be very brief. 41.05. What is the difference between the Exports(as % of merchandise exports) of Middle East & North Africa (all income levels) in 2009 and the Exports(as % of merchandise exports) of Botswana in 2010?
Offer a terse response. -59.89. What is the difference between the Exports(as % of merchandise exports) of Middle East & North Africa (all income levels) in 2009 and the Exports(as % of merchandise exports) of Morocco in 2010?
Make the answer very short. -46.68. What is the difference between the Exports(as % of merchandise exports) of Middle East & North Africa (all income levels) in 2009 and the Exports(as % of merchandise exports) of Uganda in 2010?
Your answer should be compact. -3.2. What is the difference between the Exports(as % of merchandise exports) in Botswana in 2009 and the Exports(as % of merchandise exports) in Morocco in 2010?
Ensure brevity in your answer.  11.65. What is the difference between the Exports(as % of merchandise exports) of Botswana in 2009 and the Exports(as % of merchandise exports) of Uganda in 2010?
Give a very brief answer. 55.13. What is the difference between the Exports(as % of merchandise exports) of Morocco in 2009 and the Exports(as % of merchandise exports) of Uganda in 2010?
Your answer should be compact. 41.82. What is the average Exports(as % of merchandise exports) in Middle East & North Africa (all income levels) per year?
Provide a short and direct response. 17.59. What is the average Exports(as % of merchandise exports) in Botswana per year?
Ensure brevity in your answer.  80.55. What is the average Exports(as % of merchandise exports) in Morocco per year?
Your answer should be very brief. 66.61. What is the average Exports(as % of merchandise exports) of Uganda per year?
Offer a very short reply. 19.19. In the year 2003, what is the difference between the Exports(as % of merchandise exports) in Middle East & North Africa (all income levels) and Exports(as % of merchandise exports) in Botswana?
Your answer should be very brief. -66.85. In the year 2003, what is the difference between the Exports(as % of merchandise exports) in Middle East & North Africa (all income levels) and Exports(as % of merchandise exports) in Morocco?
Keep it short and to the point. -49.04. In the year 2003, what is the difference between the Exports(as % of merchandise exports) of Middle East & North Africa (all income levels) and Exports(as % of merchandise exports) of Uganda?
Ensure brevity in your answer.  7.86. In the year 2003, what is the difference between the Exports(as % of merchandise exports) in Botswana and Exports(as % of merchandise exports) in Morocco?
Your answer should be very brief. 17.82. In the year 2003, what is the difference between the Exports(as % of merchandise exports) in Botswana and Exports(as % of merchandise exports) in Uganda?
Give a very brief answer. 74.72. In the year 2003, what is the difference between the Exports(as % of merchandise exports) of Morocco and Exports(as % of merchandise exports) of Uganda?
Offer a very short reply. 56.9. In the year 2004, what is the difference between the Exports(as % of merchandise exports) of Middle East & North Africa (all income levels) and Exports(as % of merchandise exports) of Botswana?
Give a very brief answer. -67.35. In the year 2004, what is the difference between the Exports(as % of merchandise exports) in Middle East & North Africa (all income levels) and Exports(as % of merchandise exports) in Morocco?
Offer a very short reply. -50.77. In the year 2004, what is the difference between the Exports(as % of merchandise exports) of Middle East & North Africa (all income levels) and Exports(as % of merchandise exports) of Uganda?
Make the answer very short. 7.28. In the year 2004, what is the difference between the Exports(as % of merchandise exports) of Botswana and Exports(as % of merchandise exports) of Morocco?
Keep it short and to the point. 16.58. In the year 2004, what is the difference between the Exports(as % of merchandise exports) of Botswana and Exports(as % of merchandise exports) of Uganda?
Ensure brevity in your answer.  74.63. In the year 2004, what is the difference between the Exports(as % of merchandise exports) of Morocco and Exports(as % of merchandise exports) of Uganda?
Offer a terse response. 58.05. In the year 2005, what is the difference between the Exports(as % of merchandise exports) of Middle East & North Africa (all income levels) and Exports(as % of merchandise exports) of Botswana?
Provide a succinct answer. -70.12. In the year 2005, what is the difference between the Exports(as % of merchandise exports) in Middle East & North Africa (all income levels) and Exports(as % of merchandise exports) in Morocco?
Give a very brief answer. -50.56. In the year 2005, what is the difference between the Exports(as % of merchandise exports) of Middle East & North Africa (all income levels) and Exports(as % of merchandise exports) of Uganda?
Provide a short and direct response. 3.7. In the year 2005, what is the difference between the Exports(as % of merchandise exports) of Botswana and Exports(as % of merchandise exports) of Morocco?
Give a very brief answer. 19.55. In the year 2005, what is the difference between the Exports(as % of merchandise exports) in Botswana and Exports(as % of merchandise exports) in Uganda?
Provide a succinct answer. 73.81. In the year 2005, what is the difference between the Exports(as % of merchandise exports) in Morocco and Exports(as % of merchandise exports) in Uganda?
Keep it short and to the point. 54.26. In the year 2006, what is the difference between the Exports(as % of merchandise exports) in Middle East & North Africa (all income levels) and Exports(as % of merchandise exports) in Botswana?
Provide a succinct answer. -62.46. In the year 2006, what is the difference between the Exports(as % of merchandise exports) of Middle East & North Africa (all income levels) and Exports(as % of merchandise exports) of Morocco?
Make the answer very short. -50.32. In the year 2006, what is the difference between the Exports(as % of merchandise exports) in Middle East & North Africa (all income levels) and Exports(as % of merchandise exports) in Uganda?
Ensure brevity in your answer.  -3.83. In the year 2006, what is the difference between the Exports(as % of merchandise exports) in Botswana and Exports(as % of merchandise exports) in Morocco?
Make the answer very short. 12.13. In the year 2006, what is the difference between the Exports(as % of merchandise exports) in Botswana and Exports(as % of merchandise exports) in Uganda?
Ensure brevity in your answer.  58.63. In the year 2006, what is the difference between the Exports(as % of merchandise exports) of Morocco and Exports(as % of merchandise exports) of Uganda?
Your answer should be compact. 46.49. In the year 2007, what is the difference between the Exports(as % of merchandise exports) in Middle East & North Africa (all income levels) and Exports(as % of merchandise exports) in Botswana?
Your answer should be compact. -58.79. In the year 2007, what is the difference between the Exports(as % of merchandise exports) of Middle East & North Africa (all income levels) and Exports(as % of merchandise exports) of Morocco?
Ensure brevity in your answer.  -52.26. In the year 2007, what is the difference between the Exports(as % of merchandise exports) in Middle East & North Africa (all income levels) and Exports(as % of merchandise exports) in Uganda?
Provide a short and direct response. -7.55. In the year 2007, what is the difference between the Exports(as % of merchandise exports) in Botswana and Exports(as % of merchandise exports) in Morocco?
Offer a very short reply. 6.54. In the year 2007, what is the difference between the Exports(as % of merchandise exports) in Botswana and Exports(as % of merchandise exports) in Uganda?
Make the answer very short. 51.24. In the year 2007, what is the difference between the Exports(as % of merchandise exports) in Morocco and Exports(as % of merchandise exports) in Uganda?
Your answer should be compact. 44.7. In the year 2008, what is the difference between the Exports(as % of merchandise exports) in Middle East & North Africa (all income levels) and Exports(as % of merchandise exports) in Botswana?
Make the answer very short. -61.16. In the year 2008, what is the difference between the Exports(as % of merchandise exports) of Middle East & North Africa (all income levels) and Exports(as % of merchandise exports) of Morocco?
Your answer should be very brief. -48.77. In the year 2008, what is the difference between the Exports(as % of merchandise exports) of Middle East & North Africa (all income levels) and Exports(as % of merchandise exports) of Uganda?
Offer a terse response. -12.32. In the year 2008, what is the difference between the Exports(as % of merchandise exports) of Botswana and Exports(as % of merchandise exports) of Morocco?
Your answer should be very brief. 12.38. In the year 2008, what is the difference between the Exports(as % of merchandise exports) of Botswana and Exports(as % of merchandise exports) of Uganda?
Offer a very short reply. 48.84. In the year 2008, what is the difference between the Exports(as % of merchandise exports) in Morocco and Exports(as % of merchandise exports) in Uganda?
Your response must be concise. 36.45. In the year 2009, what is the difference between the Exports(as % of merchandise exports) of Middle East & North Africa (all income levels) and Exports(as % of merchandise exports) of Botswana?
Provide a succinct answer. -58.33. In the year 2009, what is the difference between the Exports(as % of merchandise exports) in Middle East & North Africa (all income levels) and Exports(as % of merchandise exports) in Morocco?
Your answer should be very brief. -45.03. In the year 2009, what is the difference between the Exports(as % of merchandise exports) of Middle East & North Africa (all income levels) and Exports(as % of merchandise exports) of Uganda?
Offer a terse response. -5.99. In the year 2009, what is the difference between the Exports(as % of merchandise exports) in Botswana and Exports(as % of merchandise exports) in Morocco?
Provide a short and direct response. 13.3. In the year 2009, what is the difference between the Exports(as % of merchandise exports) of Botswana and Exports(as % of merchandise exports) of Uganda?
Your answer should be compact. 52.34. In the year 2009, what is the difference between the Exports(as % of merchandise exports) in Morocco and Exports(as % of merchandise exports) in Uganda?
Provide a succinct answer. 39.04. In the year 2010, what is the difference between the Exports(as % of merchandise exports) in Middle East & North Africa (all income levels) and Exports(as % of merchandise exports) in Botswana?
Ensure brevity in your answer.  -58.66. In the year 2010, what is the difference between the Exports(as % of merchandise exports) of Middle East & North Africa (all income levels) and Exports(as % of merchandise exports) of Morocco?
Offer a very short reply. -45.45. In the year 2010, what is the difference between the Exports(as % of merchandise exports) of Middle East & North Africa (all income levels) and Exports(as % of merchandise exports) of Uganda?
Provide a succinct answer. -1.98. In the year 2010, what is the difference between the Exports(as % of merchandise exports) in Botswana and Exports(as % of merchandise exports) in Morocco?
Offer a terse response. 13.21. In the year 2010, what is the difference between the Exports(as % of merchandise exports) in Botswana and Exports(as % of merchandise exports) in Uganda?
Give a very brief answer. 56.69. In the year 2010, what is the difference between the Exports(as % of merchandise exports) in Morocco and Exports(as % of merchandise exports) in Uganda?
Your response must be concise. 43.47. What is the ratio of the Exports(as % of merchandise exports) of Middle East & North Africa (all income levels) in 2003 to that in 2004?
Make the answer very short. 1.07. What is the ratio of the Exports(as % of merchandise exports) in Botswana in 2003 to that in 2004?
Give a very brief answer. 1.01. What is the ratio of the Exports(as % of merchandise exports) in Uganda in 2003 to that in 2004?
Make the answer very short. 1.06. What is the ratio of the Exports(as % of merchandise exports) of Middle East & North Africa (all income levels) in 2003 to that in 2005?
Provide a short and direct response. 1.28. What is the ratio of the Exports(as % of merchandise exports) of Botswana in 2003 to that in 2005?
Keep it short and to the point. 1.01. What is the ratio of the Exports(as % of merchandise exports) of Morocco in 2003 to that in 2005?
Make the answer very short. 1.04. What is the ratio of the Exports(as % of merchandise exports) of Uganda in 2003 to that in 2005?
Give a very brief answer. 1.01. What is the ratio of the Exports(as % of merchandise exports) in Middle East & North Africa (all income levels) in 2003 to that in 2006?
Keep it short and to the point. 1.12. What is the ratio of the Exports(as % of merchandise exports) of Botswana in 2003 to that in 2006?
Your response must be concise. 1.08. What is the ratio of the Exports(as % of merchandise exports) in Morocco in 2003 to that in 2006?
Provide a short and direct response. 1.01. What is the ratio of the Exports(as % of merchandise exports) in Uganda in 2003 to that in 2006?
Keep it short and to the point. 0.55. What is the ratio of the Exports(as % of merchandise exports) of Middle East & North Africa (all income levels) in 2003 to that in 2007?
Keep it short and to the point. 1.35. What is the ratio of the Exports(as % of merchandise exports) in Botswana in 2003 to that in 2007?
Offer a very short reply. 1.18. What is the ratio of the Exports(as % of merchandise exports) in Morocco in 2003 to that in 2007?
Give a very brief answer. 1.03. What is the ratio of the Exports(as % of merchandise exports) in Uganda in 2003 to that in 2007?
Your answer should be very brief. 0.53. What is the ratio of the Exports(as % of merchandise exports) of Middle East & North Africa (all income levels) in 2003 to that in 2008?
Your answer should be very brief. 1.29. What is the ratio of the Exports(as % of merchandise exports) of Botswana in 2003 to that in 2008?
Offer a terse response. 1.13. What is the ratio of the Exports(as % of merchandise exports) of Morocco in 2003 to that in 2008?
Offer a terse response. 1.07. What is the ratio of the Exports(as % of merchandise exports) of Uganda in 2003 to that in 2008?
Give a very brief answer. 0.43. What is the ratio of the Exports(as % of merchandise exports) of Middle East & North Africa (all income levels) in 2003 to that in 2009?
Your answer should be compact. 0.99. What is the ratio of the Exports(as % of merchandise exports) of Botswana in 2003 to that in 2009?
Ensure brevity in your answer.  1.11. What is the ratio of the Exports(as % of merchandise exports) in Morocco in 2003 to that in 2009?
Your response must be concise. 1.06. What is the ratio of the Exports(as % of merchandise exports) in Uganda in 2003 to that in 2009?
Keep it short and to the point. 0.46. What is the ratio of the Exports(as % of merchandise exports) in Middle East & North Africa (all income levels) in 2003 to that in 2010?
Make the answer very short. 0.94. What is the ratio of the Exports(as % of merchandise exports) of Botswana in 2003 to that in 2010?
Make the answer very short. 1.09. What is the ratio of the Exports(as % of merchandise exports) in Morocco in 2003 to that in 2010?
Your answer should be very brief. 1.03. What is the ratio of the Exports(as % of merchandise exports) in Uganda in 2003 to that in 2010?
Your response must be concise. 0.51. What is the ratio of the Exports(as % of merchandise exports) of Middle East & North Africa (all income levels) in 2004 to that in 2005?
Offer a terse response. 1.2. What is the ratio of the Exports(as % of merchandise exports) of Morocco in 2004 to that in 2005?
Your response must be concise. 1.05. What is the ratio of the Exports(as % of merchandise exports) in Uganda in 2004 to that in 2005?
Provide a short and direct response. 0.95. What is the ratio of the Exports(as % of merchandise exports) of Middle East & North Africa (all income levels) in 2004 to that in 2006?
Offer a terse response. 1.05. What is the ratio of the Exports(as % of merchandise exports) in Botswana in 2004 to that in 2006?
Keep it short and to the point. 1.07. What is the ratio of the Exports(as % of merchandise exports) in Morocco in 2004 to that in 2006?
Your answer should be very brief. 1.02. What is the ratio of the Exports(as % of merchandise exports) of Uganda in 2004 to that in 2006?
Make the answer very short. 0.52. What is the ratio of the Exports(as % of merchandise exports) of Middle East & North Africa (all income levels) in 2004 to that in 2007?
Your answer should be very brief. 1.26. What is the ratio of the Exports(as % of merchandise exports) of Botswana in 2004 to that in 2007?
Give a very brief answer. 1.17. What is the ratio of the Exports(as % of merchandise exports) of Morocco in 2004 to that in 2007?
Offer a terse response. 1.03. What is the ratio of the Exports(as % of merchandise exports) in Uganda in 2004 to that in 2007?
Provide a succinct answer. 0.5. What is the ratio of the Exports(as % of merchandise exports) of Middle East & North Africa (all income levels) in 2004 to that in 2008?
Offer a terse response. 1.21. What is the ratio of the Exports(as % of merchandise exports) of Botswana in 2004 to that in 2008?
Keep it short and to the point. 1.12. What is the ratio of the Exports(as % of merchandise exports) of Morocco in 2004 to that in 2008?
Give a very brief answer. 1.08. What is the ratio of the Exports(as % of merchandise exports) in Uganda in 2004 to that in 2008?
Offer a terse response. 0.4. What is the ratio of the Exports(as % of merchandise exports) in Middle East & North Africa (all income levels) in 2004 to that in 2009?
Offer a terse response. 0.93. What is the ratio of the Exports(as % of merchandise exports) in Botswana in 2004 to that in 2009?
Make the answer very short. 1.1. What is the ratio of the Exports(as % of merchandise exports) in Morocco in 2004 to that in 2009?
Provide a succinct answer. 1.07. What is the ratio of the Exports(as % of merchandise exports) of Uganda in 2004 to that in 2009?
Keep it short and to the point. 0.43. What is the ratio of the Exports(as % of merchandise exports) of Middle East & North Africa (all income levels) in 2004 to that in 2010?
Your response must be concise. 0.88. What is the ratio of the Exports(as % of merchandise exports) of Botswana in 2004 to that in 2010?
Give a very brief answer. 1.08. What is the ratio of the Exports(as % of merchandise exports) in Morocco in 2004 to that in 2010?
Provide a succinct answer. 1.04. What is the ratio of the Exports(as % of merchandise exports) in Uganda in 2004 to that in 2010?
Offer a terse response. 0.48. What is the ratio of the Exports(as % of merchandise exports) in Middle East & North Africa (all income levels) in 2005 to that in 2006?
Make the answer very short. 0.87. What is the ratio of the Exports(as % of merchandise exports) in Botswana in 2005 to that in 2006?
Make the answer very short. 1.07. What is the ratio of the Exports(as % of merchandise exports) of Morocco in 2005 to that in 2006?
Your answer should be compact. 0.97. What is the ratio of the Exports(as % of merchandise exports) in Uganda in 2005 to that in 2006?
Provide a short and direct response. 0.54. What is the ratio of the Exports(as % of merchandise exports) in Middle East & North Africa (all income levels) in 2005 to that in 2007?
Ensure brevity in your answer.  1.05. What is the ratio of the Exports(as % of merchandise exports) in Botswana in 2005 to that in 2007?
Your response must be concise. 1.16. What is the ratio of the Exports(as % of merchandise exports) of Morocco in 2005 to that in 2007?
Give a very brief answer. 0.99. What is the ratio of the Exports(as % of merchandise exports) of Uganda in 2005 to that in 2007?
Make the answer very short. 0.52. What is the ratio of the Exports(as % of merchandise exports) in Middle East & North Africa (all income levels) in 2005 to that in 2008?
Give a very brief answer. 1.01. What is the ratio of the Exports(as % of merchandise exports) of Botswana in 2005 to that in 2008?
Offer a terse response. 1.12. What is the ratio of the Exports(as % of merchandise exports) in Morocco in 2005 to that in 2008?
Give a very brief answer. 1.03. What is the ratio of the Exports(as % of merchandise exports) in Uganda in 2005 to that in 2008?
Your answer should be compact. 0.42. What is the ratio of the Exports(as % of merchandise exports) in Middle East & North Africa (all income levels) in 2005 to that in 2009?
Keep it short and to the point. 0.78. What is the ratio of the Exports(as % of merchandise exports) of Botswana in 2005 to that in 2009?
Provide a short and direct response. 1.09. What is the ratio of the Exports(as % of merchandise exports) of Morocco in 2005 to that in 2009?
Provide a succinct answer. 1.02. What is the ratio of the Exports(as % of merchandise exports) in Uganda in 2005 to that in 2009?
Make the answer very short. 0.45. What is the ratio of the Exports(as % of merchandise exports) of Middle East & North Africa (all income levels) in 2005 to that in 2010?
Offer a very short reply. 0.73. What is the ratio of the Exports(as % of merchandise exports) in Botswana in 2005 to that in 2010?
Your answer should be compact. 1.07. What is the ratio of the Exports(as % of merchandise exports) in Morocco in 2005 to that in 2010?
Offer a terse response. 0.99. What is the ratio of the Exports(as % of merchandise exports) of Uganda in 2005 to that in 2010?
Keep it short and to the point. 0.5. What is the ratio of the Exports(as % of merchandise exports) of Middle East & North Africa (all income levels) in 2006 to that in 2007?
Keep it short and to the point. 1.21. What is the ratio of the Exports(as % of merchandise exports) in Botswana in 2006 to that in 2007?
Offer a terse response. 1.09. What is the ratio of the Exports(as % of merchandise exports) in Morocco in 2006 to that in 2007?
Your answer should be very brief. 1.02. What is the ratio of the Exports(as % of merchandise exports) in Uganda in 2006 to that in 2007?
Give a very brief answer. 0.97. What is the ratio of the Exports(as % of merchandise exports) of Middle East & North Africa (all income levels) in 2006 to that in 2008?
Keep it short and to the point. 1.16. What is the ratio of the Exports(as % of merchandise exports) of Botswana in 2006 to that in 2008?
Give a very brief answer. 1.05. What is the ratio of the Exports(as % of merchandise exports) in Morocco in 2006 to that in 2008?
Provide a succinct answer. 1.06. What is the ratio of the Exports(as % of merchandise exports) in Uganda in 2006 to that in 2008?
Provide a short and direct response. 0.78. What is the ratio of the Exports(as % of merchandise exports) in Middle East & North Africa (all income levels) in 2006 to that in 2009?
Offer a very short reply. 0.89. What is the ratio of the Exports(as % of merchandise exports) in Botswana in 2006 to that in 2009?
Ensure brevity in your answer.  1.03. What is the ratio of the Exports(as % of merchandise exports) of Morocco in 2006 to that in 2009?
Offer a terse response. 1.05. What is the ratio of the Exports(as % of merchandise exports) in Uganda in 2006 to that in 2009?
Your answer should be very brief. 0.83. What is the ratio of the Exports(as % of merchandise exports) of Middle East & North Africa (all income levels) in 2006 to that in 2010?
Your answer should be very brief. 0.84. What is the ratio of the Exports(as % of merchandise exports) in Botswana in 2006 to that in 2010?
Offer a terse response. 1.01. What is the ratio of the Exports(as % of merchandise exports) in Morocco in 2006 to that in 2010?
Offer a very short reply. 1.02. What is the ratio of the Exports(as % of merchandise exports) in Uganda in 2006 to that in 2010?
Provide a succinct answer. 0.93. What is the ratio of the Exports(as % of merchandise exports) in Middle East & North Africa (all income levels) in 2007 to that in 2008?
Offer a very short reply. 0.96. What is the ratio of the Exports(as % of merchandise exports) of Botswana in 2007 to that in 2008?
Give a very brief answer. 0.96. What is the ratio of the Exports(as % of merchandise exports) in Morocco in 2007 to that in 2008?
Offer a very short reply. 1.04. What is the ratio of the Exports(as % of merchandise exports) in Uganda in 2007 to that in 2008?
Provide a succinct answer. 0.8. What is the ratio of the Exports(as % of merchandise exports) in Middle East & North Africa (all income levels) in 2007 to that in 2009?
Your response must be concise. 0.74. What is the ratio of the Exports(as % of merchandise exports) of Morocco in 2007 to that in 2009?
Provide a succinct answer. 1.03. What is the ratio of the Exports(as % of merchandise exports) of Uganda in 2007 to that in 2009?
Your answer should be very brief. 0.86. What is the ratio of the Exports(as % of merchandise exports) of Middle East & North Africa (all income levels) in 2007 to that in 2010?
Offer a terse response. 0.69. What is the ratio of the Exports(as % of merchandise exports) in Botswana in 2007 to that in 2010?
Give a very brief answer. 0.92. What is the ratio of the Exports(as % of merchandise exports) in Morocco in 2007 to that in 2010?
Your answer should be very brief. 1.01. What is the ratio of the Exports(as % of merchandise exports) in Uganda in 2007 to that in 2010?
Give a very brief answer. 0.97. What is the ratio of the Exports(as % of merchandise exports) in Middle East & North Africa (all income levels) in 2008 to that in 2009?
Give a very brief answer. 0.77. What is the ratio of the Exports(as % of merchandise exports) of Botswana in 2008 to that in 2009?
Provide a short and direct response. 0.98. What is the ratio of the Exports(as % of merchandise exports) in Uganda in 2008 to that in 2009?
Ensure brevity in your answer.  1.07. What is the ratio of the Exports(as % of merchandise exports) of Middle East & North Africa (all income levels) in 2008 to that in 2010?
Your response must be concise. 0.72. What is the ratio of the Exports(as % of merchandise exports) in Botswana in 2008 to that in 2010?
Make the answer very short. 0.96. What is the ratio of the Exports(as % of merchandise exports) of Morocco in 2008 to that in 2010?
Offer a very short reply. 0.96. What is the ratio of the Exports(as % of merchandise exports) of Uganda in 2008 to that in 2010?
Your answer should be compact. 1.2. What is the ratio of the Exports(as % of merchandise exports) in Middle East & North Africa (all income levels) in 2009 to that in 2010?
Your answer should be very brief. 0.94. What is the ratio of the Exports(as % of merchandise exports) in Botswana in 2009 to that in 2010?
Offer a terse response. 0.98. What is the ratio of the Exports(as % of merchandise exports) in Morocco in 2009 to that in 2010?
Offer a terse response. 0.98. What is the ratio of the Exports(as % of merchandise exports) in Uganda in 2009 to that in 2010?
Your answer should be compact. 1.12. What is the difference between the highest and the second highest Exports(as % of merchandise exports) of Middle East & North Africa (all income levels)?
Make the answer very short. 1.23. What is the difference between the highest and the second highest Exports(as % of merchandise exports) in Botswana?
Keep it short and to the point. 0.76. What is the difference between the highest and the second highest Exports(as % of merchandise exports) in Morocco?
Offer a terse response. 0.48. What is the difference between the highest and the second highest Exports(as % of merchandise exports) of Uganda?
Provide a short and direct response. 1.82. What is the difference between the highest and the lowest Exports(as % of merchandise exports) in Middle East & North Africa (all income levels)?
Provide a short and direct response. 6.37. What is the difference between the highest and the lowest Exports(as % of merchandise exports) in Botswana?
Offer a terse response. 13.09. What is the difference between the highest and the lowest Exports(as % of merchandise exports) of Morocco?
Ensure brevity in your answer.  5.15. What is the difference between the highest and the lowest Exports(as % of merchandise exports) in Uganda?
Your answer should be compact. 16.45. 